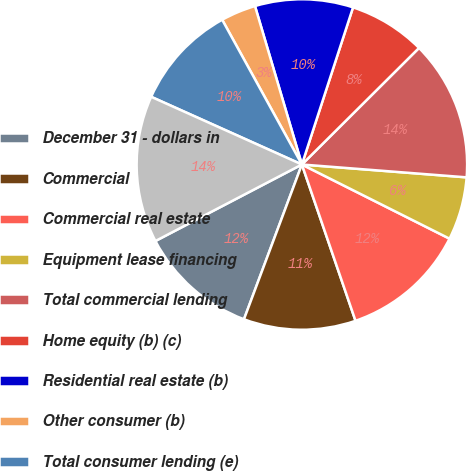Convert chart. <chart><loc_0><loc_0><loc_500><loc_500><pie_chart><fcel>December 31 - dollars in<fcel>Commercial<fcel>Commercial real estate<fcel>Equipment lease financing<fcel>Total commercial lending<fcel>Home equity (b) (c)<fcel>Residential real estate (b)<fcel>Other consumer (b)<fcel>Total consumer lending (e)<fcel>Total nonperforming loans (f)<nl><fcel>11.64%<fcel>10.96%<fcel>12.33%<fcel>6.17%<fcel>13.7%<fcel>7.53%<fcel>9.59%<fcel>3.43%<fcel>10.27%<fcel>14.38%<nl></chart> 